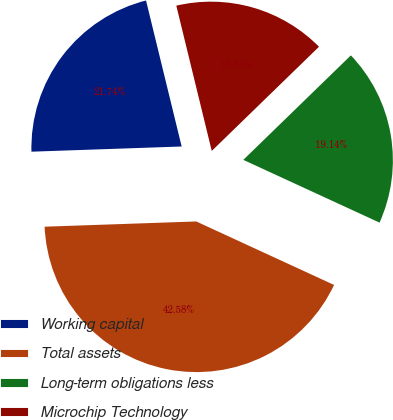Convert chart. <chart><loc_0><loc_0><loc_500><loc_500><pie_chart><fcel>Working capital<fcel>Total assets<fcel>Long-term obligations less<fcel>Microchip Technology<nl><fcel>21.74%<fcel>42.58%<fcel>19.14%<fcel>16.54%<nl></chart> 